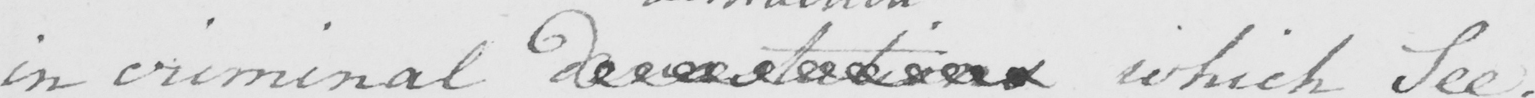What is written in this line of handwriting? in criminal  <gap/>  which See . 